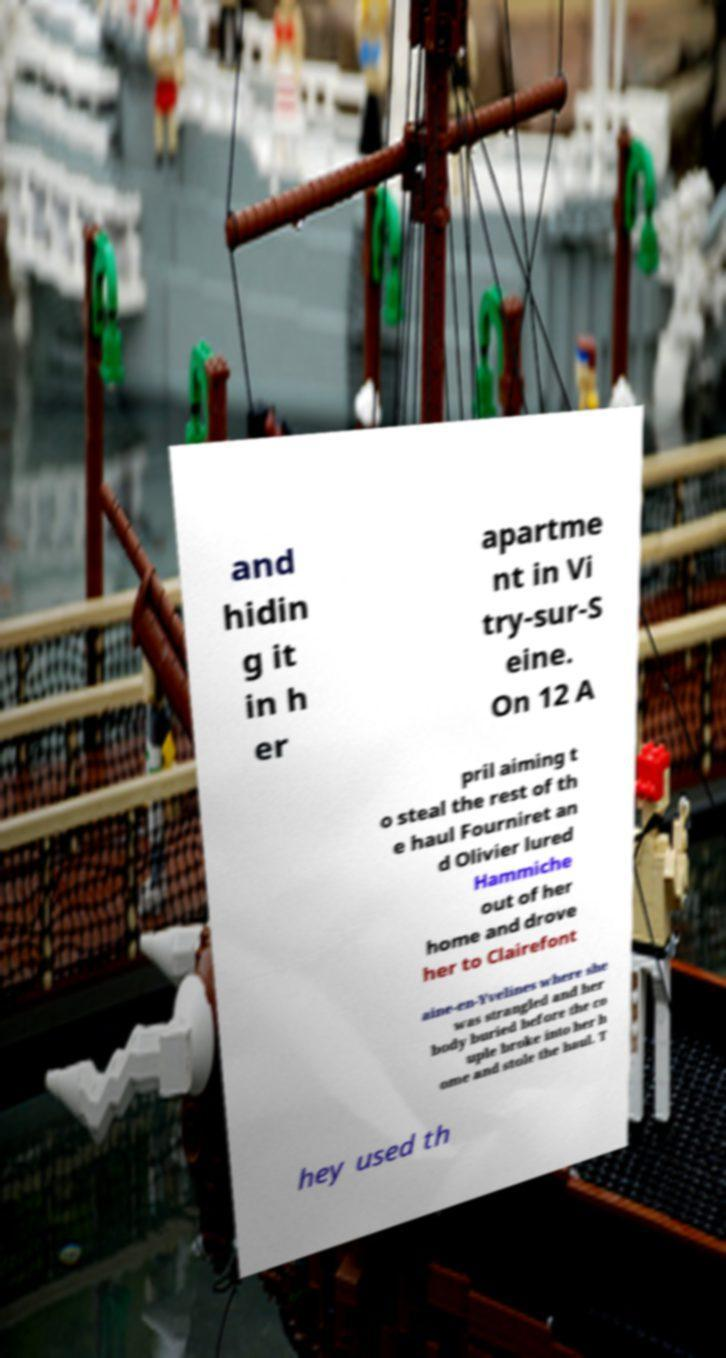For documentation purposes, I need the text within this image transcribed. Could you provide that? and hidin g it in h er apartme nt in Vi try-sur-S eine. On 12 A pril aiming t o steal the rest of th e haul Fourniret an d Olivier lured Hammiche out of her home and drove her to Clairefont aine-en-Yvelines where she was strangled and her body buried before the co uple broke into her h ome and stole the haul. T hey used th 